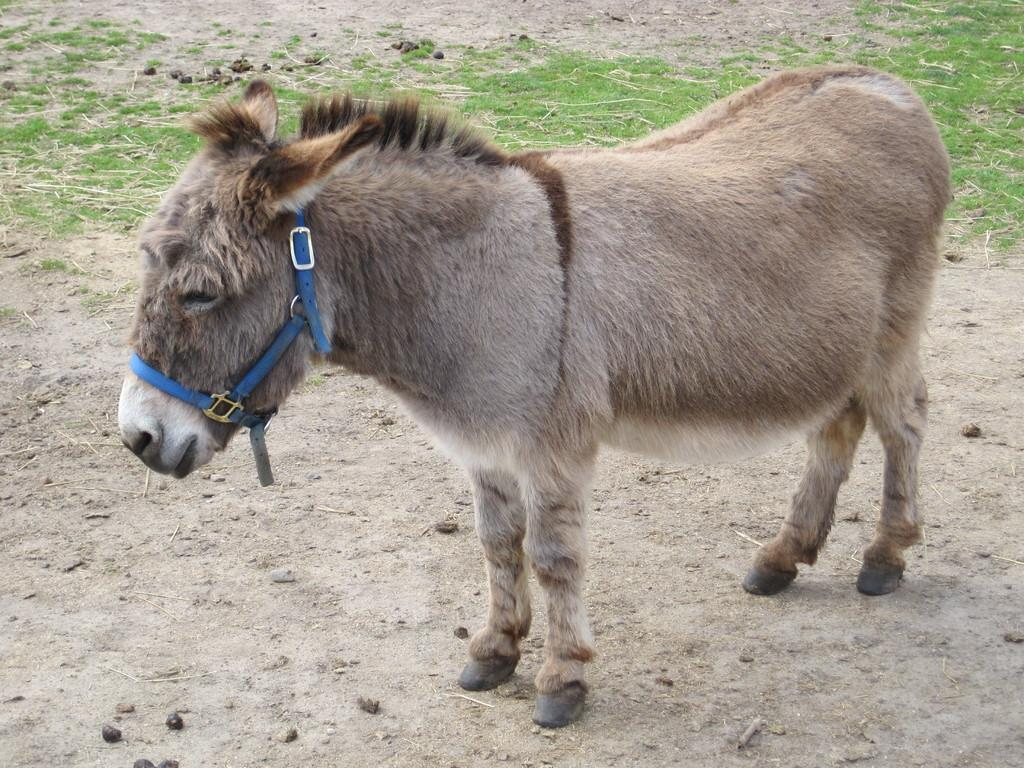What is the main subject in the center of the image? There is a donkey in the center of the image. What is attached to the donkey's face? A belt is attached to the donkey's face. What type of vegetation can be seen in the background of the image? There is grass in the background of the image. What type of ground is visible in the background of the image? Soil is visible in the background of the image. What type of quince is hanging from the donkey's ear in the image? There is no quince present in the image, and the donkey's ear is not mentioned in the facts provided. 